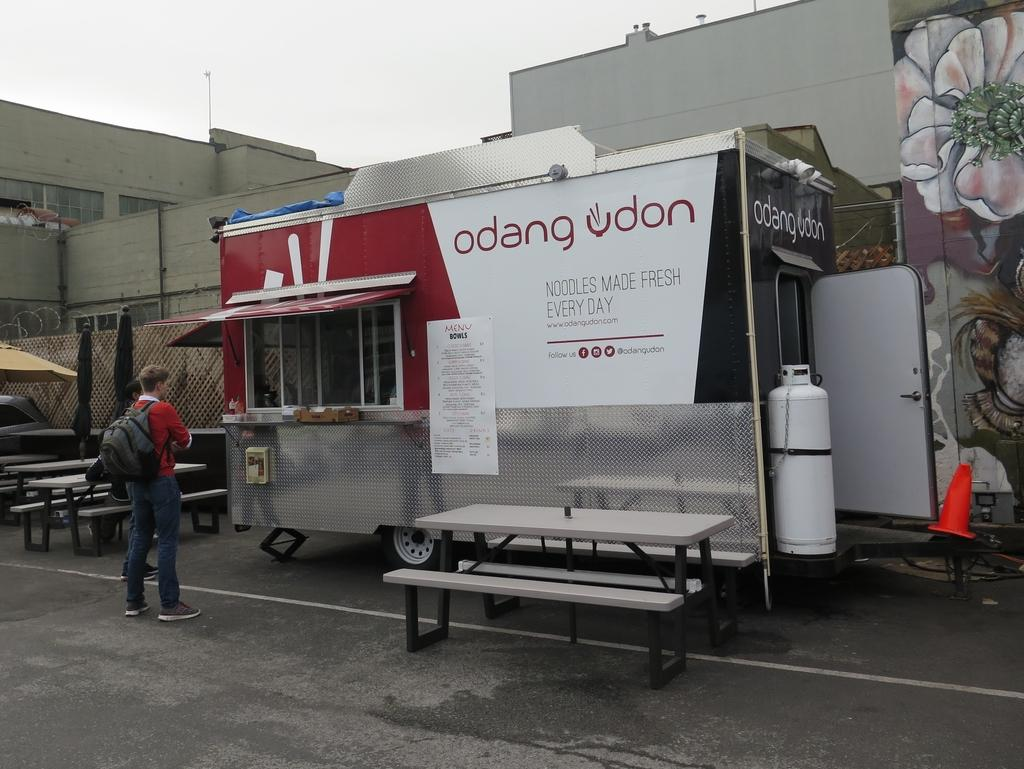Who is present in the image? There is a man in the image. What is the man doing in the image? The man is standing in the image. What is the man carrying in the image? The man is carrying a backpack in the image. What can be seen behind the man in the image? There is a food truck in front of the man in the image. How much profit did the man make from selling books in the image? There is no mention of books or selling in the image, so it is impossible to determine any profit made. 